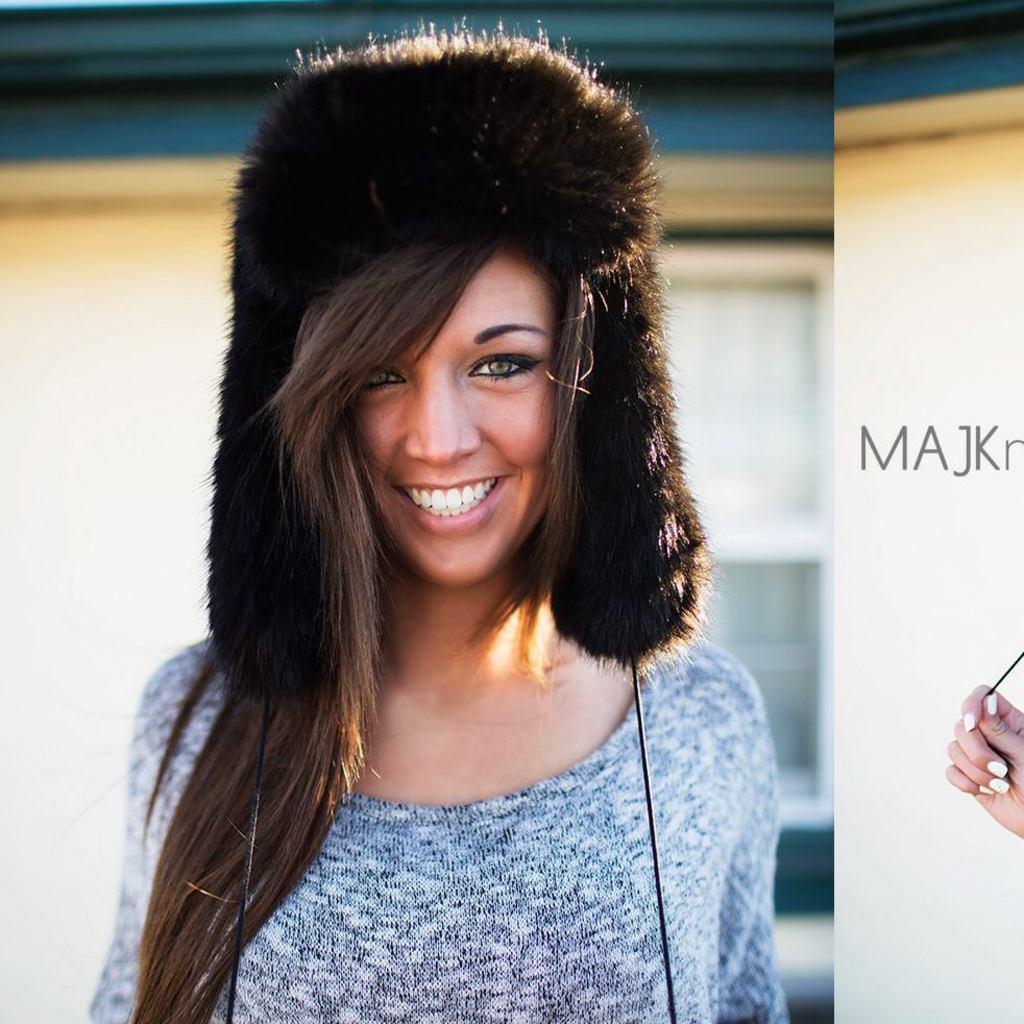Could you give a brief overview of what you see in this image? In this image, we can see a person wearing clothes. There is a person hand in the bottom right of the image. There is a text on the right side of the image. In the background, image is blurred. 